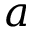<formula> <loc_0><loc_0><loc_500><loc_500>a</formula> 